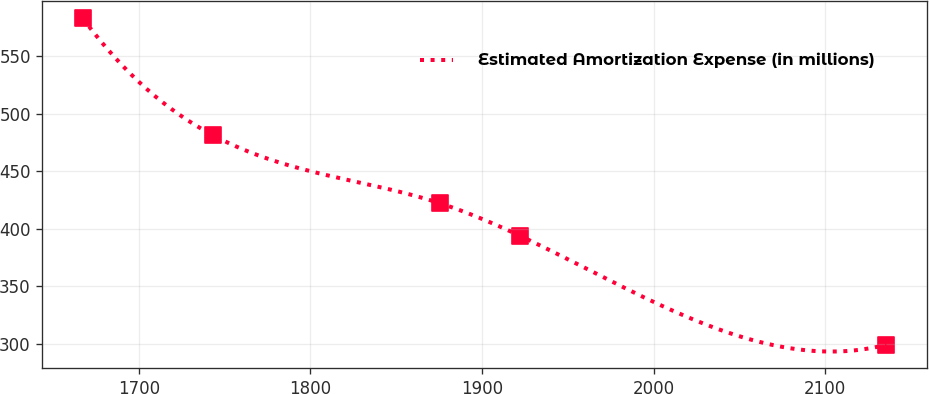Convert chart. <chart><loc_0><loc_0><loc_500><loc_500><line_chart><ecel><fcel>Estimated Amortization Expense (in millions)<nl><fcel>1667.28<fcel>582.95<nl><fcel>1743.25<fcel>481.16<nl><fcel>1875.34<fcel>422.19<nl><fcel>1922.18<fcel>393.82<nl><fcel>2135.65<fcel>299.24<nl></chart> 